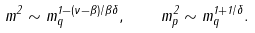<formula> <loc_0><loc_0><loc_500><loc_500>m ^ { 2 } \sim m _ { q } ^ { 1 - ( \nu - \beta ) / \beta \delta } , \quad m _ { p } ^ { 2 } \sim m _ { q } ^ { 1 + 1 / \delta } .</formula> 